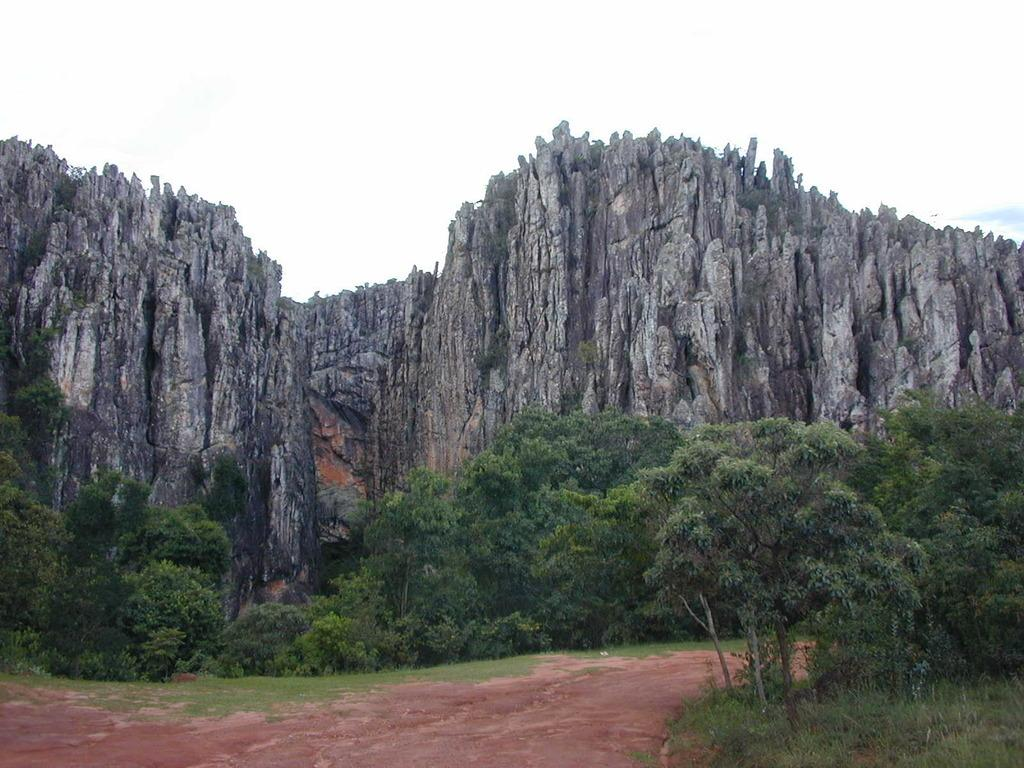What type of geographical feature is present in the image? There are rock mountains in the image. What can be seen at the base of the rock mountains? There are trees, plants, and grass at the bottom of the image. Is there any man-made structure visible in the image? Yes, there is a walkway at the bottom of the image. What type of watch is visible on the rock mountain in the image? There is no watch present in the image; it features rock mountains, trees, plants, grass, and a walkway. Can you tell me what kind of lunch is being served on the rock mountain in the image? There is no lunch or any food item present in the image; it only shows rock mountains, trees, plants, grass, and a walkway. 